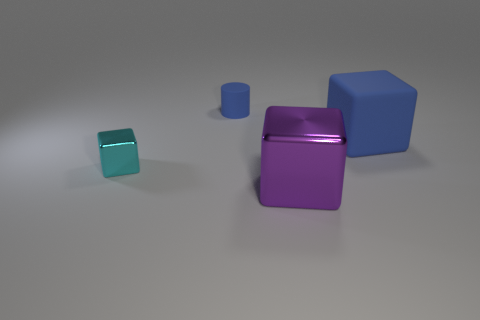Subtract all tiny blocks. How many blocks are left? 2 Add 3 small blocks. How many objects exist? 7 Subtract all cylinders. How many objects are left? 3 Subtract 1 blocks. How many blocks are left? 2 Subtract all brown cylinders. Subtract all cyan blocks. How many cylinders are left? 1 Subtract all small balls. Subtract all small matte objects. How many objects are left? 3 Add 4 large cubes. How many large cubes are left? 6 Add 3 shiny objects. How many shiny objects exist? 5 Subtract all blue blocks. How many blocks are left? 2 Subtract 0 purple cylinders. How many objects are left? 4 